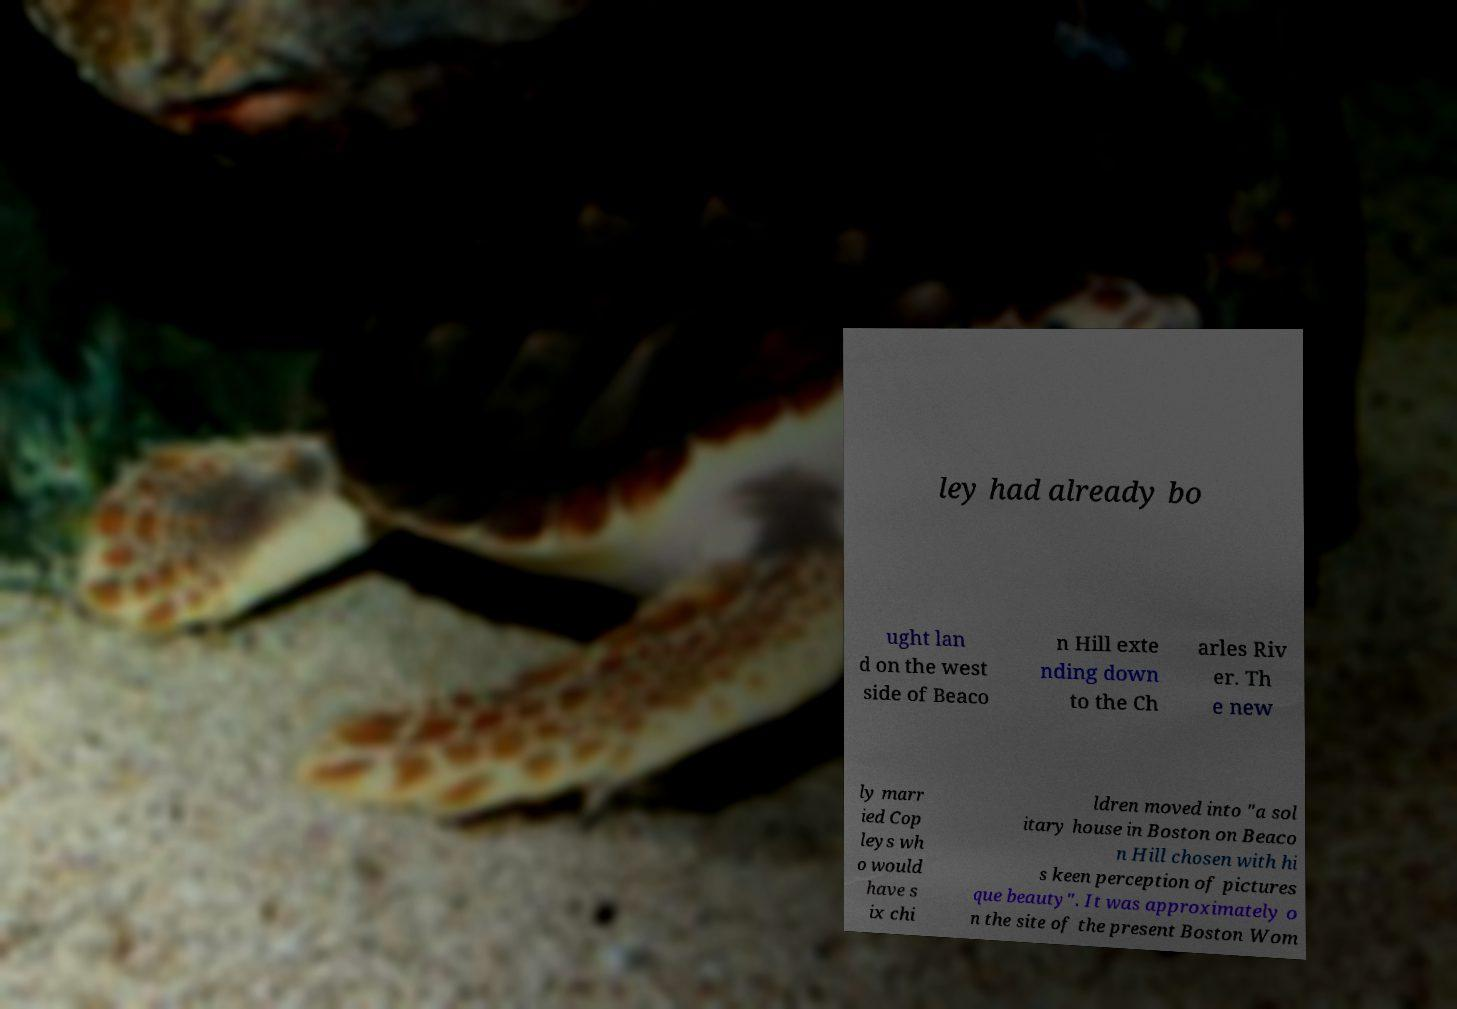Please read and relay the text visible in this image. What does it say? ley had already bo ught lan d on the west side of Beaco n Hill exte nding down to the Ch arles Riv er. Th e new ly marr ied Cop leys wh o would have s ix chi ldren moved into "a sol itary house in Boston on Beaco n Hill chosen with hi s keen perception of pictures que beauty". It was approximately o n the site of the present Boston Wom 